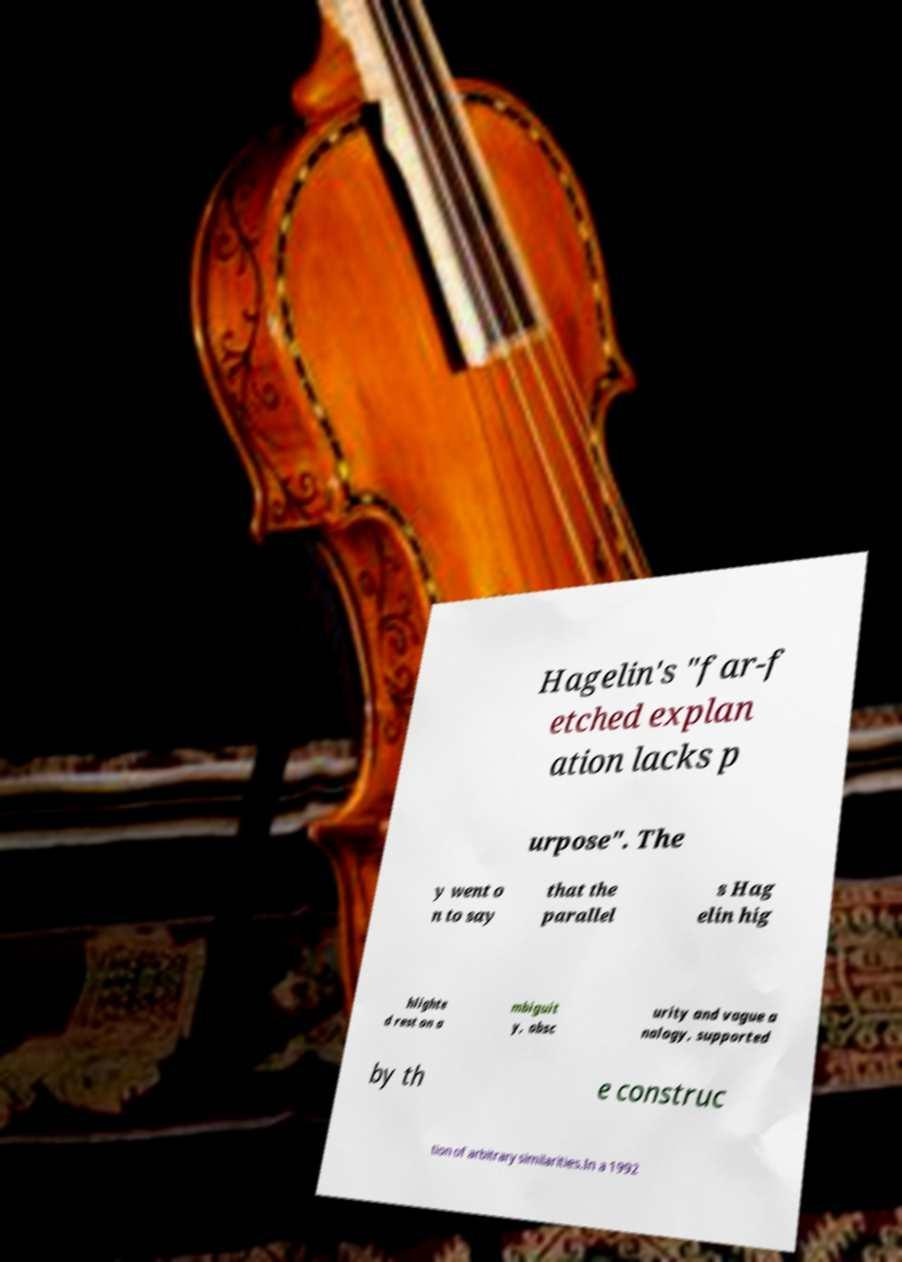Could you extract and type out the text from this image? Hagelin's "far-f etched explan ation lacks p urpose". The y went o n to say that the parallel s Hag elin hig hlighte d rest on a mbiguit y, obsc urity and vague a nalogy, supported by th e construc tion of arbitrary similarities.In a 1992 